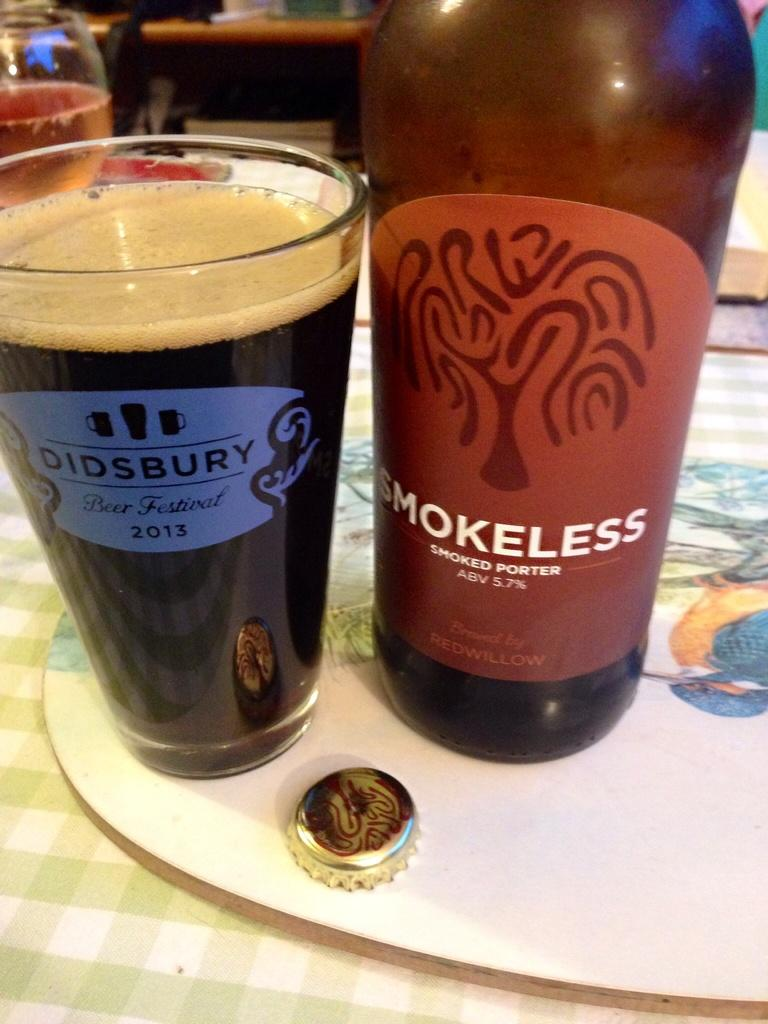<image>
Provide a brief description of the given image. The beer named Smokeless is a porter type beer. 